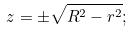<formula> <loc_0><loc_0><loc_500><loc_500>z = \pm \sqrt { R ^ { 2 } - r ^ { 2 } } ;</formula> 